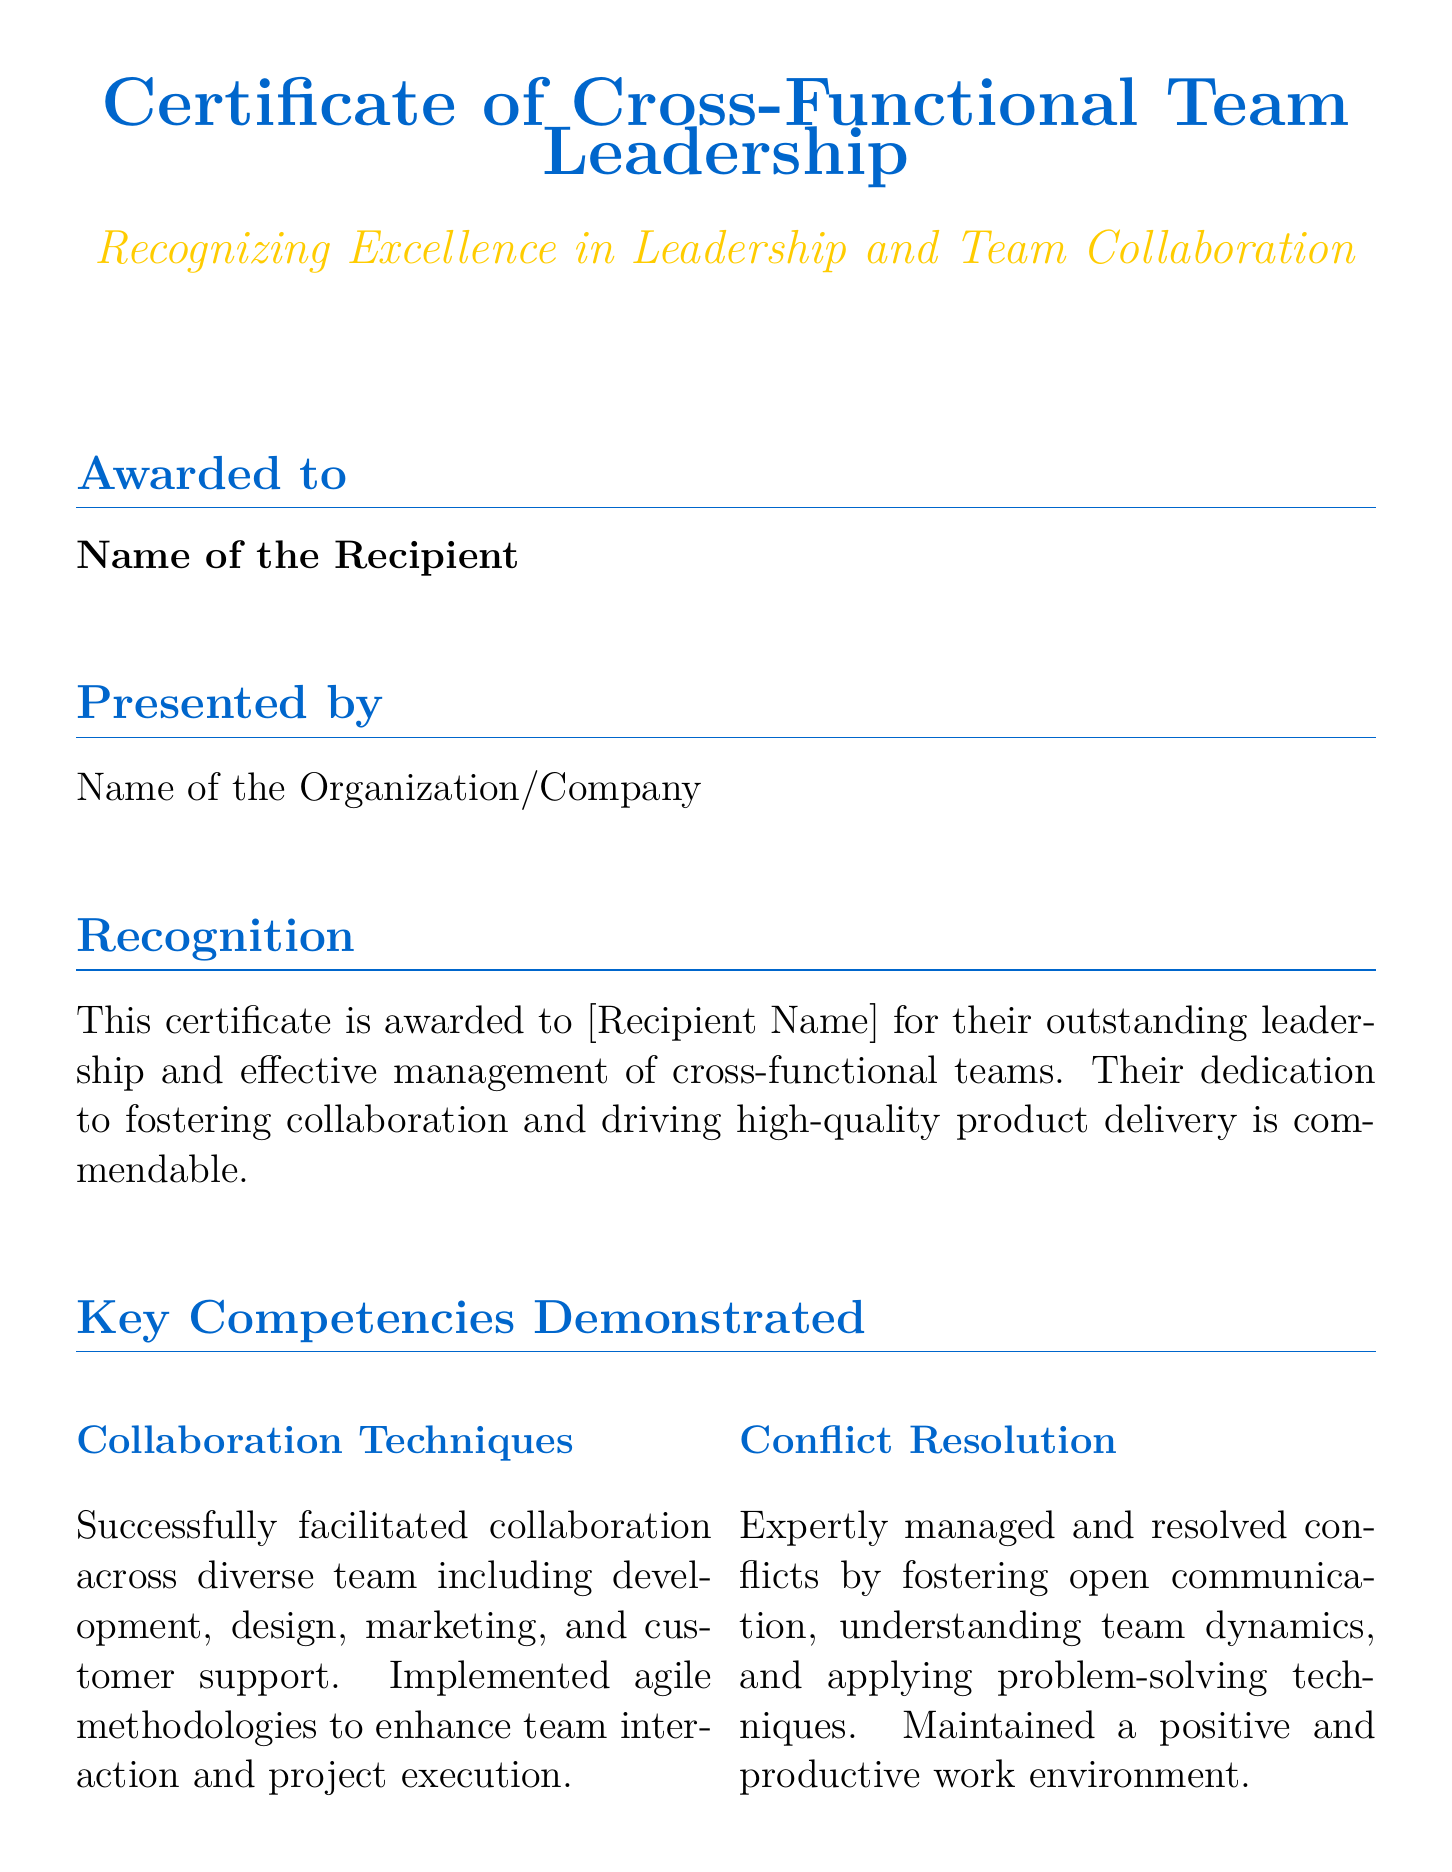What is the title of the document? The title is prominently displayed at the top of the document and states the purpose of the certificate.
Answer: Certificate of Cross-Functional Team Leadership Who is the recipient of the award? The recipient's name is included in the section titled "Awarded to," showing who has received the certificate.
Answer: Name of the Recipient What organization presented the certificate? The organization is listed in the section titled "Presented by," indicating who issued the certificate.
Answer: Name of the Organization/Company What is one key competency demonstrated in the document? The document lists several key competencies, such as collaboration techniques or conflict resolution.
Answer: Collaboration Techniques What does the certificate recognize? The recognition section describes the purpose of awarding the certificate.
Answer: Outstanding leadership and effective management What was the outcome of the specific product or project mentioned? The achievements section reports the impact of the project or product, revealing its success.
Answer: Exceeded user expectations Who signed the certificate as Chief Product Officer? The signatory for the Chief Product Officer position is listed in the document, indicating who authorized it.
Answer: Name of the CPO What two roles are listed for signatories? The document has designated roles for individuals who signed the certificate, reflecting a formal acknowledgment.
Answer: Chief Product Officer and CEO 